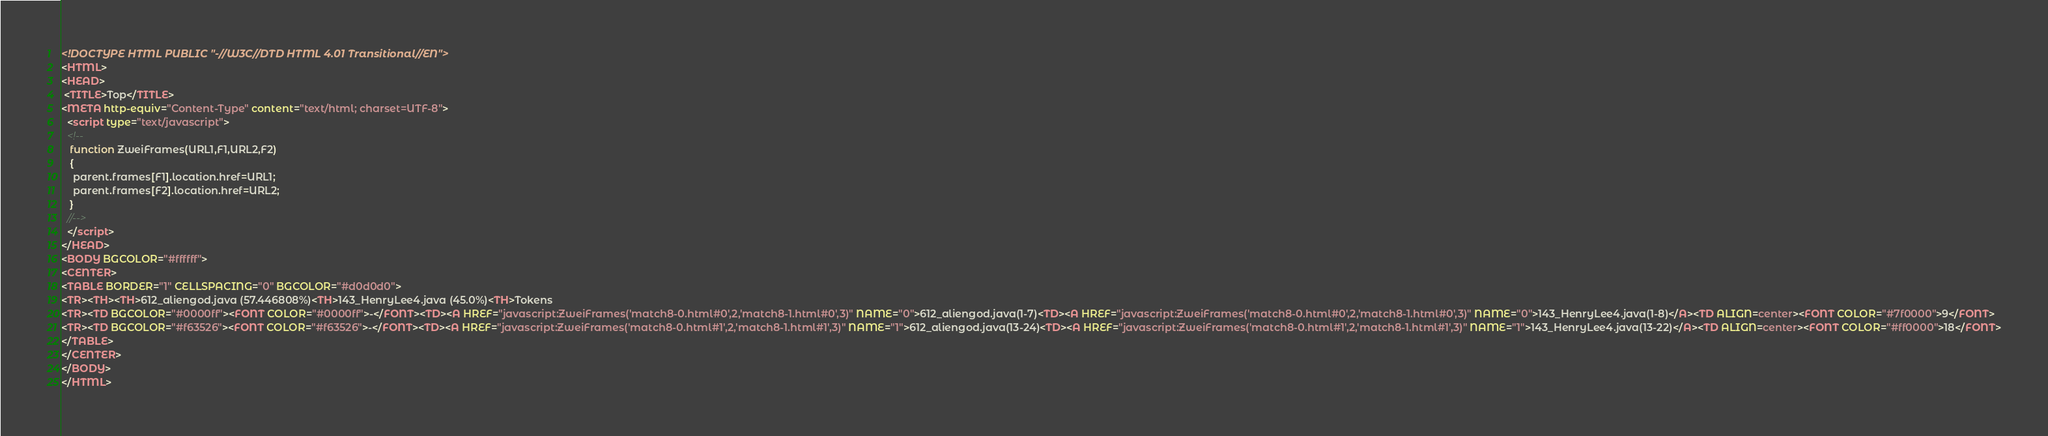<code> <loc_0><loc_0><loc_500><loc_500><_HTML_><!DOCTYPE HTML PUBLIC "-//W3C//DTD HTML 4.01 Transitional//EN">
<HTML>
<HEAD>
 <TITLE>Top</TITLE>
<META http-equiv="Content-Type" content="text/html; charset=UTF-8">
  <script type="text/javascript">
  <!--
   function ZweiFrames(URL1,F1,URL2,F2)
   {
    parent.frames[F1].location.href=URL1;
    parent.frames[F2].location.href=URL2;
   }
  //-->
  </script>
</HEAD>
<BODY BGCOLOR="#ffffff">
<CENTER>
<TABLE BORDER="1" CELLSPACING="0" BGCOLOR="#d0d0d0">
<TR><TH><TH>612_aliengod.java (57.446808%)<TH>143_HenryLee4.java (45.0%)<TH>Tokens
<TR><TD BGCOLOR="#0000ff"><FONT COLOR="#0000ff">-</FONT><TD><A HREF="javascript:ZweiFrames('match8-0.html#0',2,'match8-1.html#0',3)" NAME="0">612_aliengod.java(1-7)<TD><A HREF="javascript:ZweiFrames('match8-0.html#0',2,'match8-1.html#0',3)" NAME="0">143_HenryLee4.java(1-8)</A><TD ALIGN=center><FONT COLOR="#7f0000">9</FONT>
<TR><TD BGCOLOR="#f63526"><FONT COLOR="#f63526">-</FONT><TD><A HREF="javascript:ZweiFrames('match8-0.html#1',2,'match8-1.html#1',3)" NAME="1">612_aliengod.java(13-24)<TD><A HREF="javascript:ZweiFrames('match8-0.html#1',2,'match8-1.html#1',3)" NAME="1">143_HenryLee4.java(13-22)</A><TD ALIGN=center><FONT COLOR="#ff0000">18</FONT>
</TABLE>
</CENTER>
</BODY>
</HTML>

</code> 